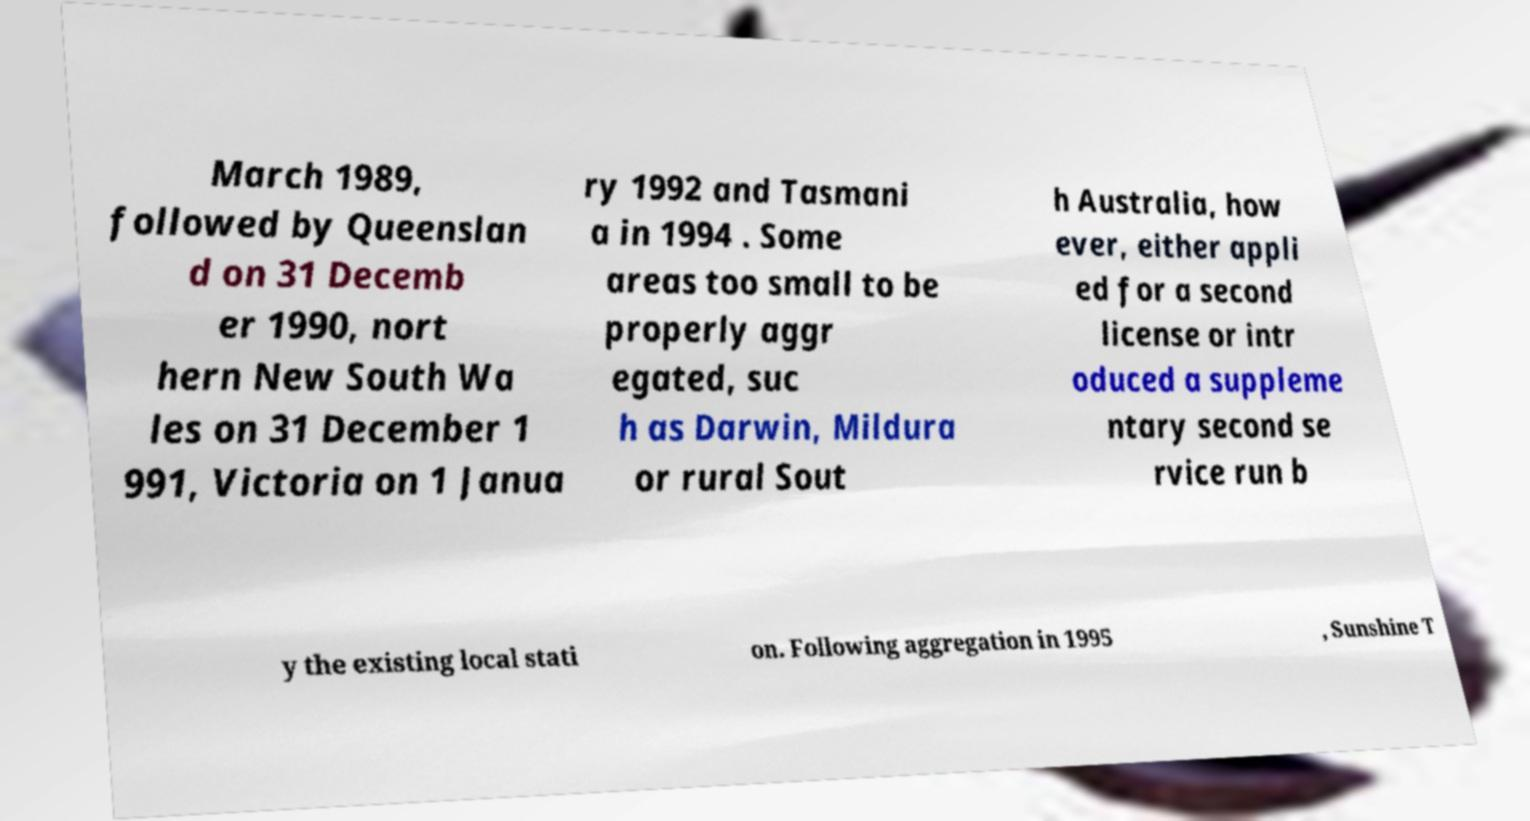Please read and relay the text visible in this image. What does it say? March 1989, followed by Queenslan d on 31 Decemb er 1990, nort hern New South Wa les on 31 December 1 991, Victoria on 1 Janua ry 1992 and Tasmani a in 1994 . Some areas too small to be properly aggr egated, suc h as Darwin, Mildura or rural Sout h Australia, how ever, either appli ed for a second license or intr oduced a suppleme ntary second se rvice run b y the existing local stati on. Following aggregation in 1995 , Sunshine T 